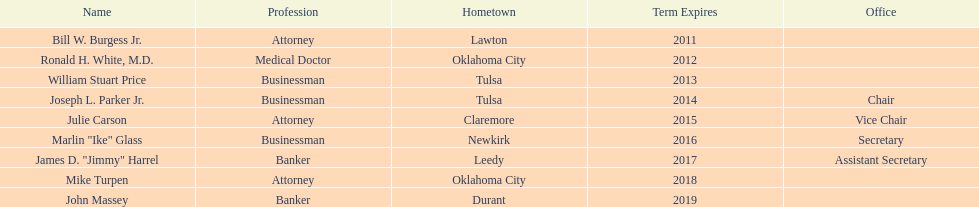Which state regent originates from the same hometown as ronald h. white, m.d.? Mike Turpen. 